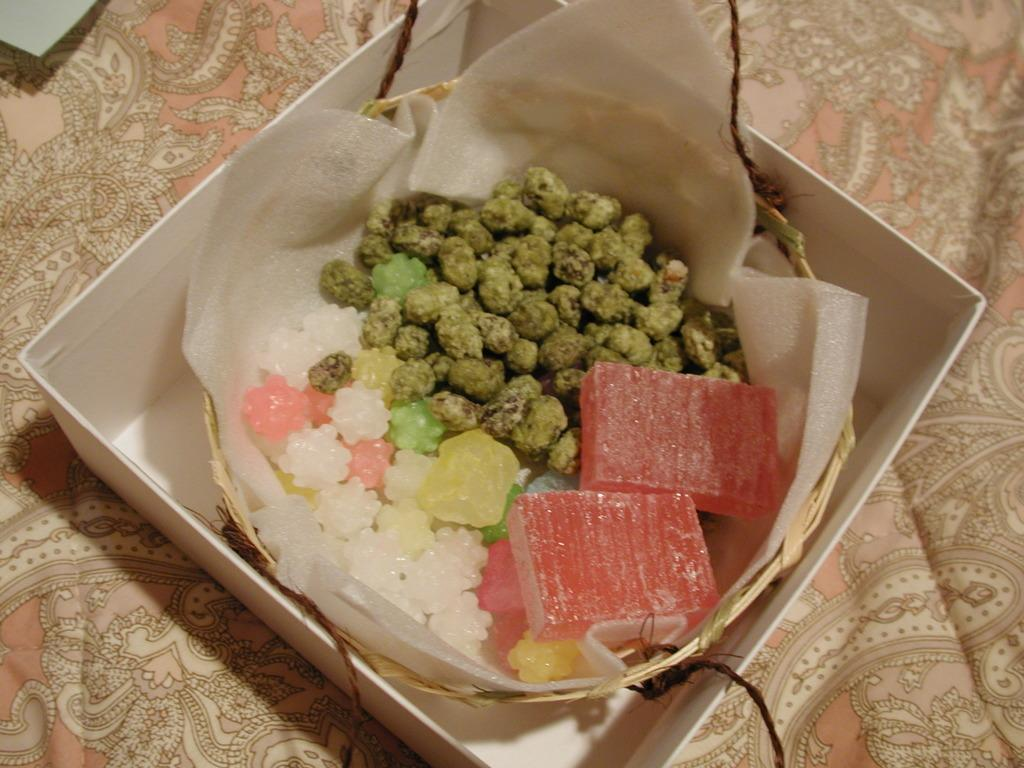What object is the main focus of the image? There is a box in the image. What is inside the box? Inside the box, there is a bowl. What is in the bowl? The bowl contains a food item. How many dogs are sleeping in the box in the image? There are no dogs present in the image, and the box does not show any signs of sleep. 